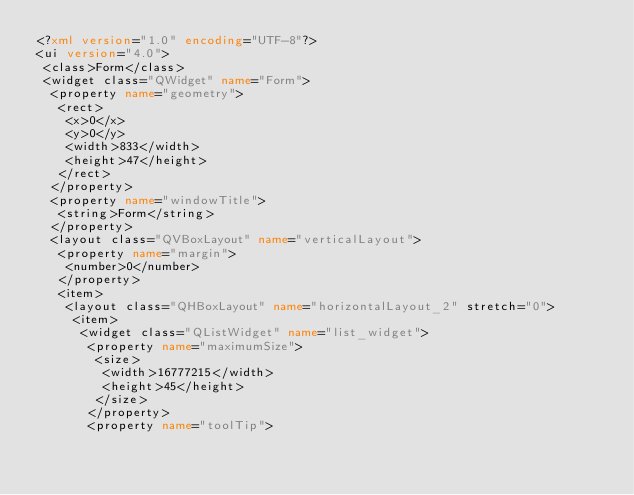<code> <loc_0><loc_0><loc_500><loc_500><_XML_><?xml version="1.0" encoding="UTF-8"?>
<ui version="4.0">
 <class>Form</class>
 <widget class="QWidget" name="Form">
  <property name="geometry">
   <rect>
    <x>0</x>
    <y>0</y>
    <width>833</width>
    <height>47</height>
   </rect>
  </property>
  <property name="windowTitle">
   <string>Form</string>
  </property>
  <layout class="QVBoxLayout" name="verticalLayout">
   <property name="margin">
    <number>0</number>
   </property>
   <item>
    <layout class="QHBoxLayout" name="horizontalLayout_2" stretch="0">
     <item>
      <widget class="QListWidget" name="list_widget">
       <property name="maximumSize">
        <size>
         <width>16777215</width>
         <height>45</height>
        </size>
       </property>
       <property name="toolTip"></code> 